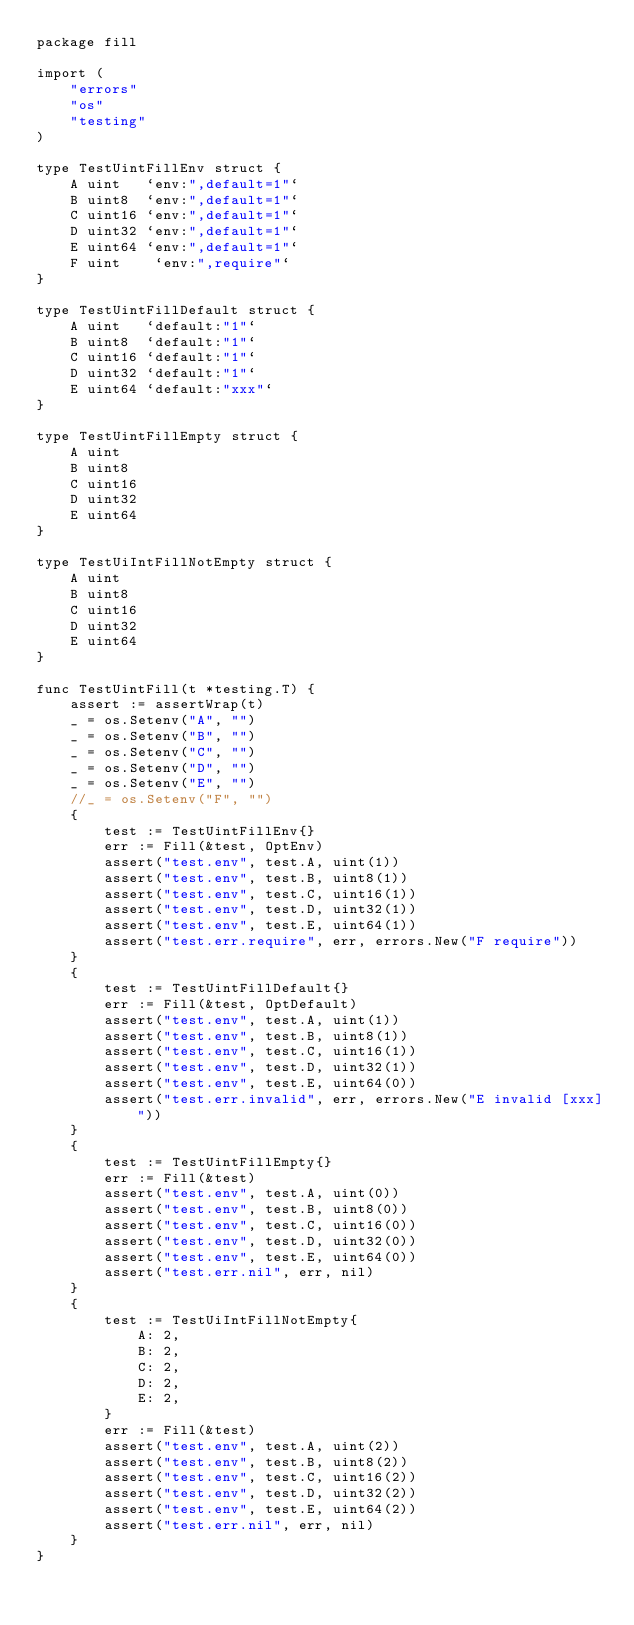<code> <loc_0><loc_0><loc_500><loc_500><_Go_>package fill

import (
    "errors"
    "os"
    "testing"
)

type TestUintFillEnv struct {
    A uint   `env:",default=1"`
    B uint8  `env:",default=1"`
    C uint16 `env:",default=1"`
    D uint32 `env:",default=1"`
    E uint64 `env:",default=1"`
    F uint    `env:",require"`
}

type TestUintFillDefault struct {
    A uint   `default:"1"`
    B uint8  `default:"1"`
    C uint16 `default:"1"`
    D uint32 `default:"1"`
    E uint64 `default:"xxx"`
}

type TestUintFillEmpty struct {
    A uint
    B uint8
    C uint16
    D uint32
    E uint64
}

type TestUiIntFillNotEmpty struct {
    A uint
    B uint8
    C uint16
    D uint32
    E uint64
}

func TestUintFill(t *testing.T) {
    assert := assertWrap(t)
    _ = os.Setenv("A", "")
    _ = os.Setenv("B", "")
    _ = os.Setenv("C", "")
    _ = os.Setenv("D", "")
    _ = os.Setenv("E", "")
    //_ = os.Setenv("F", "")
    {
        test := TestUintFillEnv{}
        err := Fill(&test, OptEnv)
        assert("test.env", test.A, uint(1))
        assert("test.env", test.B, uint8(1))
        assert("test.env", test.C, uint16(1))
        assert("test.env", test.D, uint32(1))
        assert("test.env", test.E, uint64(1))
        assert("test.err.require", err, errors.New("F require"))
    }
    {
        test := TestUintFillDefault{}
        err := Fill(&test, OptDefault)
        assert("test.env", test.A, uint(1))
        assert("test.env", test.B, uint8(1))
        assert("test.env", test.C, uint16(1))
        assert("test.env", test.D, uint32(1))
        assert("test.env", test.E, uint64(0))
        assert("test.err.invalid", err, errors.New("E invalid [xxx]"))
    }
    {
        test := TestUintFillEmpty{}
        err := Fill(&test)
        assert("test.env", test.A, uint(0))
        assert("test.env", test.B, uint8(0))
        assert("test.env", test.C, uint16(0))
        assert("test.env", test.D, uint32(0))
        assert("test.env", test.E, uint64(0))
        assert("test.err.nil", err, nil)
    }
    {
        test := TestUiIntFillNotEmpty{
            A: 2,
            B: 2,
            C: 2,
            D: 2,
            E: 2,
        }
        err := Fill(&test)
        assert("test.env", test.A, uint(2))
        assert("test.env", test.B, uint8(2))
        assert("test.env", test.C, uint16(2))
        assert("test.env", test.D, uint32(2))
        assert("test.env", test.E, uint64(2))
        assert("test.err.nil", err, nil)
    }
}
</code> 